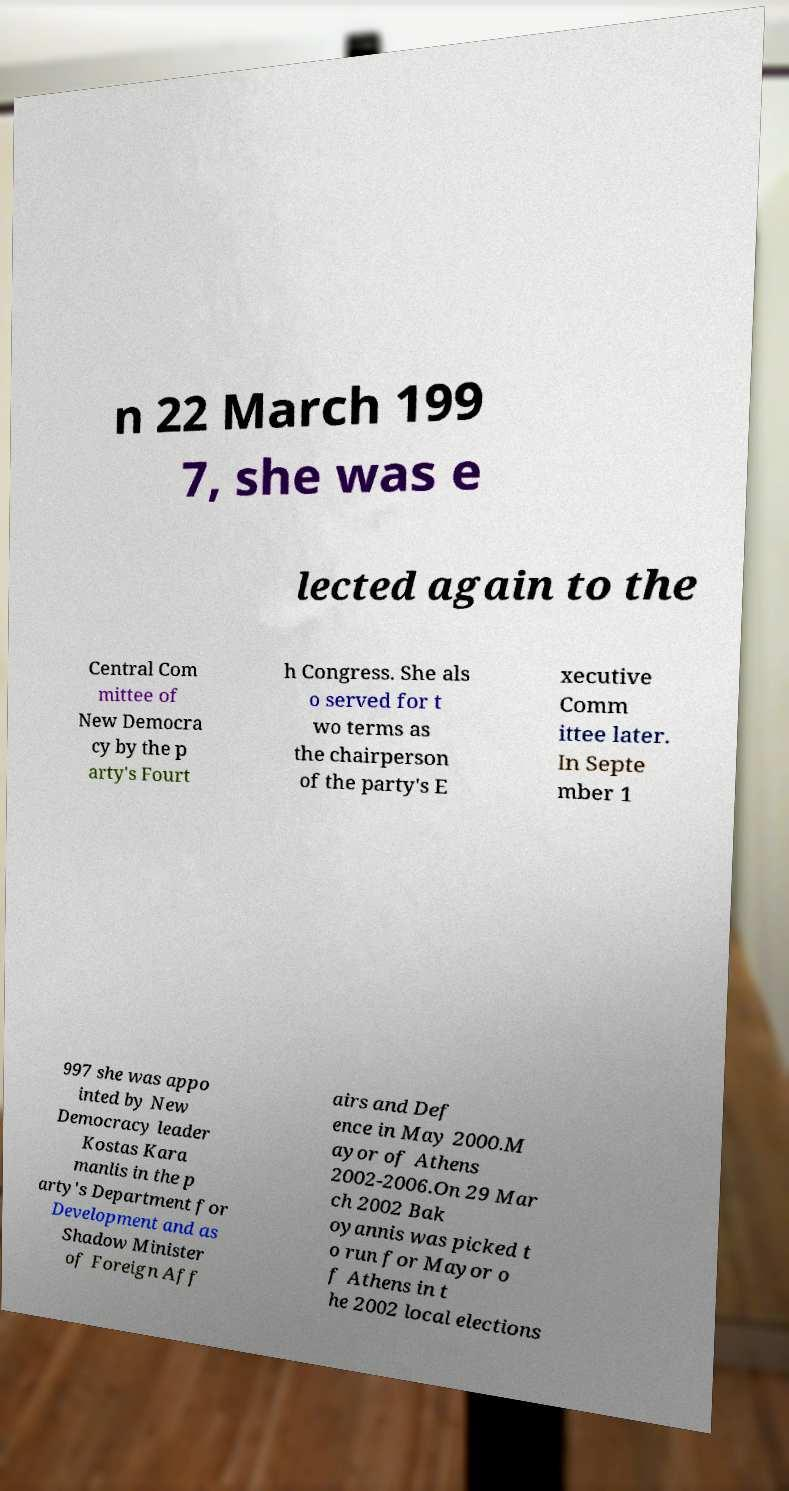Please identify and transcribe the text found in this image. n 22 March 199 7, she was e lected again to the Central Com mittee of New Democra cy by the p arty's Fourt h Congress. She als o served for t wo terms as the chairperson of the party's E xecutive Comm ittee later. In Septe mber 1 997 she was appo inted by New Democracy leader Kostas Kara manlis in the p arty's Department for Development and as Shadow Minister of Foreign Aff airs and Def ence in May 2000.M ayor of Athens 2002-2006.On 29 Mar ch 2002 Bak oyannis was picked t o run for Mayor o f Athens in t he 2002 local elections 